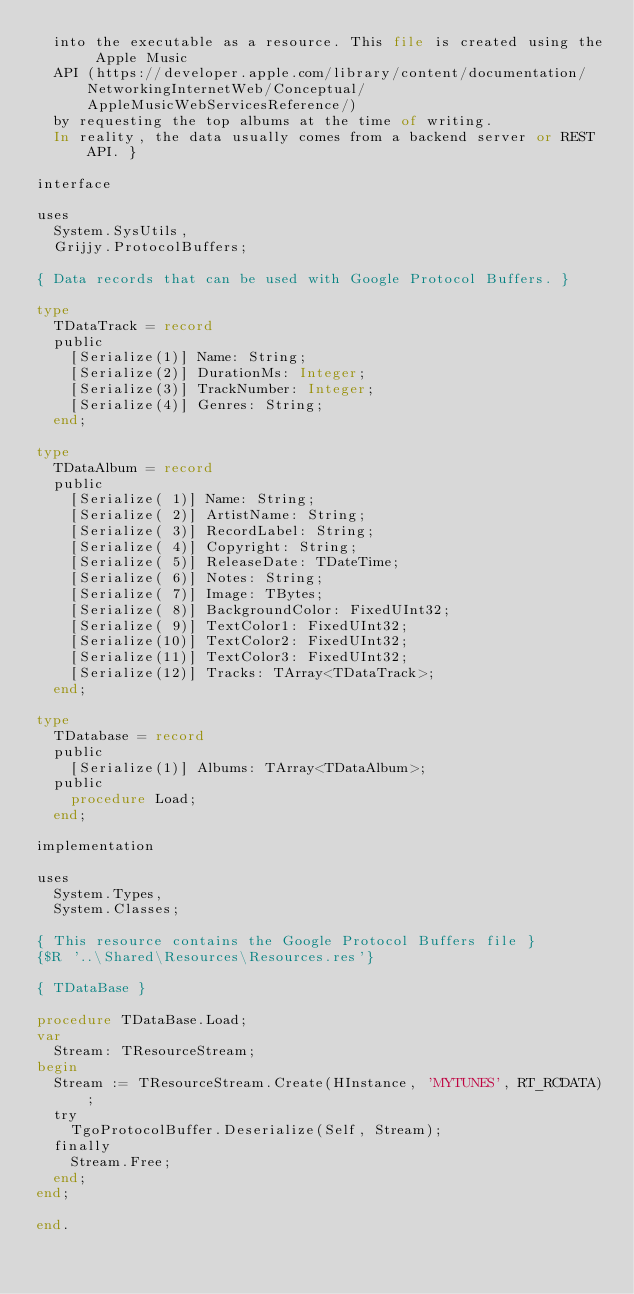<code> <loc_0><loc_0><loc_500><loc_500><_Pascal_>  into the executable as a resource. This file is created using the Apple Music
  API (https://developer.apple.com/library/content/documentation/NetworkingInternetWeb/Conceptual/AppleMusicWebServicesReference/)
  by requesting the top albums at the time of writing.
  In reality, the data usually comes from a backend server or REST API. }

interface

uses
  System.SysUtils,
  Grijjy.ProtocolBuffers;

{ Data records that can be used with Google Protocol Buffers. }

type
  TDataTrack = record
  public
    [Serialize(1)] Name: String;
    [Serialize(2)] DurationMs: Integer;
    [Serialize(3)] TrackNumber: Integer;
    [Serialize(4)] Genres: String;
  end;

type
  TDataAlbum = record
  public
    [Serialize( 1)] Name: String;
    [Serialize( 2)] ArtistName: String;
    [Serialize( 3)] RecordLabel: String;
    [Serialize( 4)] Copyright: String;
    [Serialize( 5)] ReleaseDate: TDateTime;
    [Serialize( 6)] Notes: String;
    [Serialize( 7)] Image: TBytes;
    [Serialize( 8)] BackgroundColor: FixedUInt32;
    [Serialize( 9)] TextColor1: FixedUInt32;
    [Serialize(10)] TextColor2: FixedUInt32;
    [Serialize(11)] TextColor3: FixedUInt32;
    [Serialize(12)] Tracks: TArray<TDataTrack>;
  end;

type
  TDatabase = record
  public
    [Serialize(1)] Albums: TArray<TDataAlbum>;
  public
    procedure Load;
  end;

implementation

uses
  System.Types,
  System.Classes;

{ This resource contains the Google Protocol Buffers file }
{$R '..\Shared\Resources\Resources.res'}

{ TDataBase }

procedure TDataBase.Load;
var
  Stream: TResourceStream;
begin
  Stream := TResourceStream.Create(HInstance, 'MYTUNES', RT_RCDATA);
  try
    TgoProtocolBuffer.Deserialize(Self, Stream);
  finally
    Stream.Free;
  end;
end;

end.
</code> 